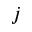<formula> <loc_0><loc_0><loc_500><loc_500>j</formula> 